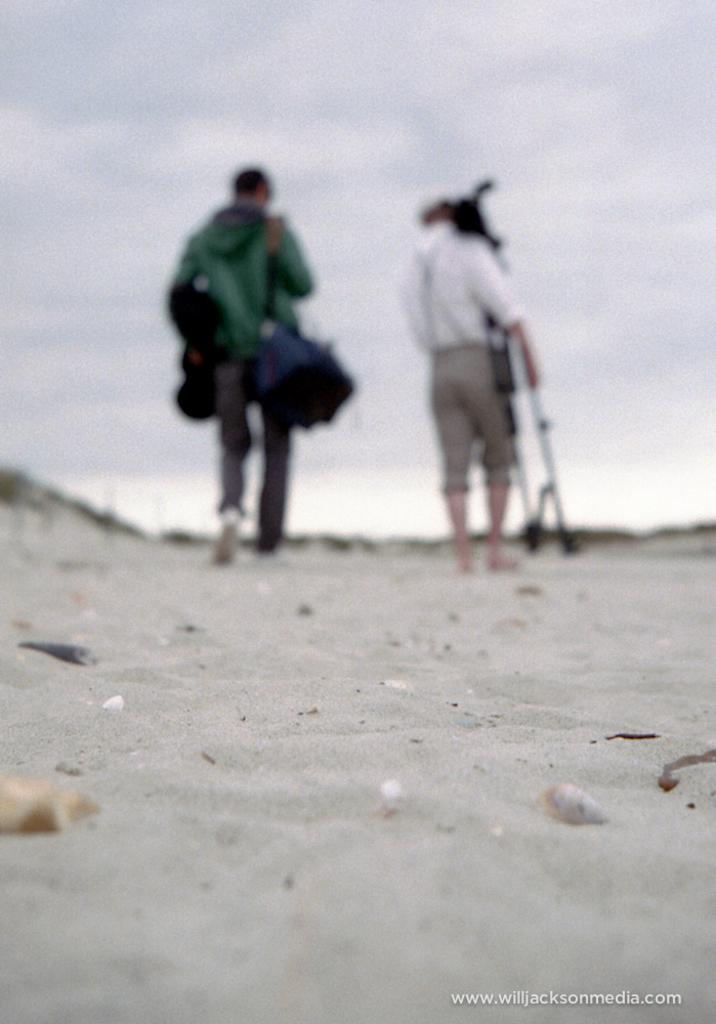How many people are in the image? There are two people in the image. What are the people doing in the image? The people are walking on sand. What are the people holding in the image? The people are holding objects in the image. What is visible at the top of the image? The sky is visible at the top of the image. What can be observed in the sky? Clouds are present in the sky. What is the condition of the protest in the image? There is no protest present in the image. How long have the people been resting in the image? The people are not resting in the image; they are walking on sand. 